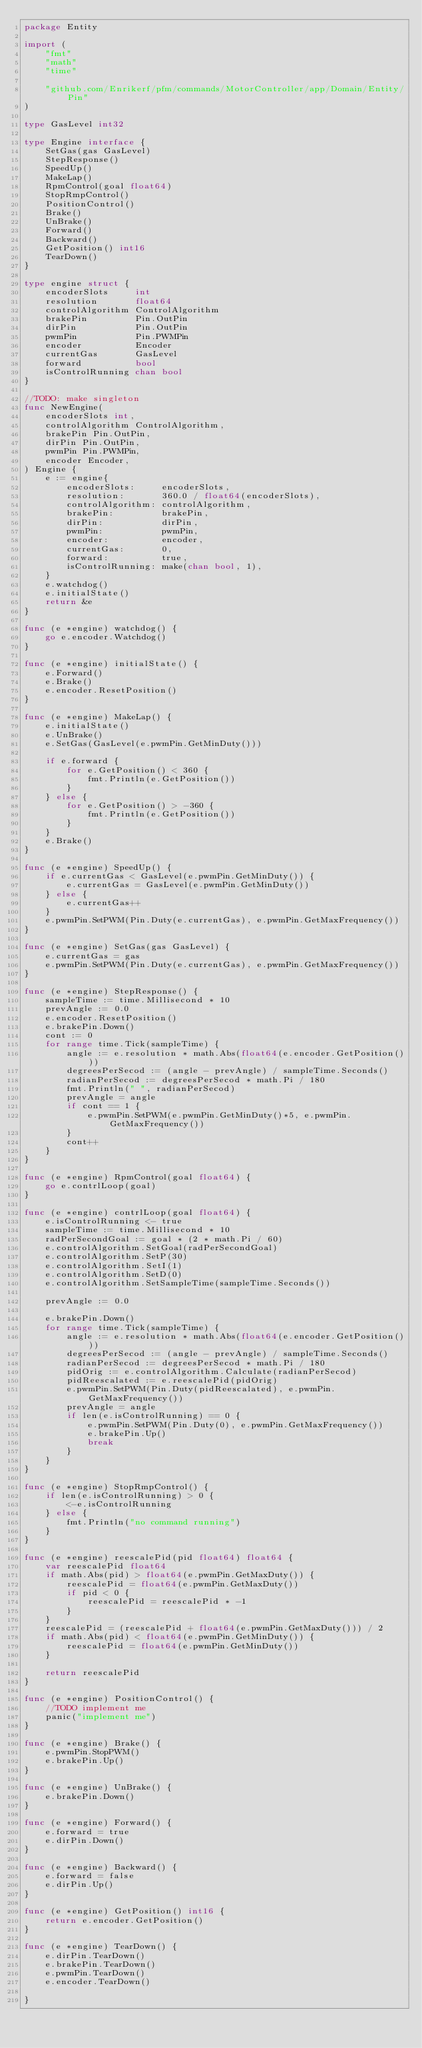Convert code to text. <code><loc_0><loc_0><loc_500><loc_500><_Go_>package Entity

import (
	"fmt"
	"math"
	"time"

	"github.com/Enrikerf/pfm/commands/MotorController/app/Domain/Entity/Pin"
)

type GasLevel int32

type Engine interface {
	SetGas(gas GasLevel)
	StepResponse()
	SpeedUp()
	MakeLap()
	RpmControl(goal float64)
	StopRmpControl()
	PositionControl()
	Brake()
	UnBrake()
	Forward()
	Backward()
	GetPosition() int16
	TearDown()
}

type engine struct {
	encoderSlots     int
	resolution       float64
	controlAlgorithm ControlAlgorithm
	brakePin         Pin.OutPin
	dirPin           Pin.OutPin
	pwmPin           Pin.PWMPin
	encoder          Encoder
	currentGas       GasLevel
	forward          bool
	isControlRunning chan bool
}

//TODO: make singleton
func NewEngine(
	encoderSlots int,
	controlAlgorithm ControlAlgorithm,
	brakePin Pin.OutPin,
	dirPin Pin.OutPin,
	pwmPin Pin.PWMPin,
	encoder Encoder,
) Engine {
	e := engine{
		encoderSlots:     encoderSlots,
		resolution:       360.0 / float64(encoderSlots),
		controlAlgorithm: controlAlgorithm,
		brakePin:         brakePin,
		dirPin:           dirPin,
		pwmPin:           pwmPin,
		encoder:          encoder,
		currentGas:       0,
		forward:          true,
		isControlRunning: make(chan bool, 1),
	}
	e.watchdog()
	e.initialState()
	return &e
}

func (e *engine) watchdog() {
	go e.encoder.Watchdog()
}

func (e *engine) initialState() {
	e.Forward()
	e.Brake()
	e.encoder.ResetPosition()
}

func (e *engine) MakeLap() {
	e.initialState()
	e.UnBrake()
	e.SetGas(GasLevel(e.pwmPin.GetMinDuty()))

	if e.forward {
		for e.GetPosition() < 360 {
			fmt.Println(e.GetPosition())
		}
	} else {
		for e.GetPosition() > -360 {
			fmt.Println(e.GetPosition())
		}
	}
	e.Brake()
}

func (e *engine) SpeedUp() {
	if e.currentGas < GasLevel(e.pwmPin.GetMinDuty()) {
		e.currentGas = GasLevel(e.pwmPin.GetMinDuty())
	} else {
		e.currentGas++
	}
	e.pwmPin.SetPWM(Pin.Duty(e.currentGas), e.pwmPin.GetMaxFrequency())
}

func (e *engine) SetGas(gas GasLevel) {
	e.currentGas = gas
	e.pwmPin.SetPWM(Pin.Duty(e.currentGas), e.pwmPin.GetMaxFrequency())
}

func (e *engine) StepResponse() {
	sampleTime := time.Millisecond * 10
	prevAngle := 0.0
	e.encoder.ResetPosition()
	e.brakePin.Down()
	cont := 0
	for range time.Tick(sampleTime) {
		angle := e.resolution * math.Abs(float64(e.encoder.GetPosition()))
		degreesPerSecod := (angle - prevAngle) / sampleTime.Seconds()
		radianPerSecod := degreesPerSecod * math.Pi / 180
		fmt.Println(" ", radianPerSecod)
		prevAngle = angle
		if cont == 1 {
			e.pwmPin.SetPWM(e.pwmPin.GetMinDuty()*5, e.pwmPin.GetMaxFrequency())
		}
		cont++
	}
}

func (e *engine) RpmControl(goal float64) {
	go e.contrlLoop(goal)
}

func (e *engine) contrlLoop(goal float64) {
	e.isControlRunning <- true
	sampleTime := time.Millisecond * 10
	radPerSecondGoal := goal * (2 * math.Pi / 60)
	e.controlAlgorithm.SetGoal(radPerSecondGoal)
	e.controlAlgorithm.SetP(30)
	e.controlAlgorithm.SetI(1)
	e.controlAlgorithm.SetD(0)
	e.controlAlgorithm.SetSampleTime(sampleTime.Seconds())

	prevAngle := 0.0

	e.brakePin.Down()
	for range time.Tick(sampleTime) {
		angle := e.resolution * math.Abs(float64(e.encoder.GetPosition()))
		degreesPerSecod := (angle - prevAngle) / sampleTime.Seconds()
		radianPerSecod := degreesPerSecod * math.Pi / 180
		pidOrig := e.controlAlgorithm.Calculate(radianPerSecod)
		pidReescalated := e.reescalePid(pidOrig)
		e.pwmPin.SetPWM(Pin.Duty(pidReescalated), e.pwmPin.GetMaxFrequency())
		prevAngle = angle
		if len(e.isControlRunning) == 0 {
			e.pwmPin.SetPWM(Pin.Duty(0), e.pwmPin.GetMaxFrequency())
			e.brakePin.Up()
			break
		}
	}
}

func (e *engine) StopRmpControl() {
	if len(e.isControlRunning) > 0 {
		<-e.isControlRunning
	} else {
		fmt.Println("no command running")
	}
}

func (e *engine) reescalePid(pid float64) float64 {
	var reescalePid float64
	if math.Abs(pid) > float64(e.pwmPin.GetMaxDuty()) {
		reescalePid = float64(e.pwmPin.GetMaxDuty())
		if pid < 0 {
			reescalePid = reescalePid * -1
		}
	}
	reescalePid = (reescalePid + float64(e.pwmPin.GetMaxDuty())) / 2
	if math.Abs(pid) < float64(e.pwmPin.GetMinDuty()) {
		reescalePid = float64(e.pwmPin.GetMinDuty())
	}

	return reescalePid
}

func (e *engine) PositionControl() {
	//TODO implement me
	panic("implement me")
}

func (e *engine) Brake() {
	e.pwmPin.StopPWM()
	e.brakePin.Up()
}

func (e *engine) UnBrake() {
	e.brakePin.Down()
}

func (e *engine) Forward() {
	e.forward = true
	e.dirPin.Down()
}

func (e *engine) Backward() {
	e.forward = false
	e.dirPin.Up()
}

func (e *engine) GetPosition() int16 {
	return e.encoder.GetPosition()
}

func (e *engine) TearDown() {
	e.dirPin.TearDown()
	e.brakePin.TearDown()
	e.pwmPin.TearDown()
	e.encoder.TearDown()

}
</code> 